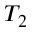Convert formula to latex. <formula><loc_0><loc_0><loc_500><loc_500>T _ { 2 }</formula> 